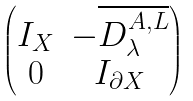Convert formula to latex. <formula><loc_0><loc_0><loc_500><loc_500>\begin{pmatrix} I _ { X } & - \overline { D _ { \lambda } ^ { { A } , { L } } } \\ 0 & I _ { \partial X } \end{pmatrix}</formula> 